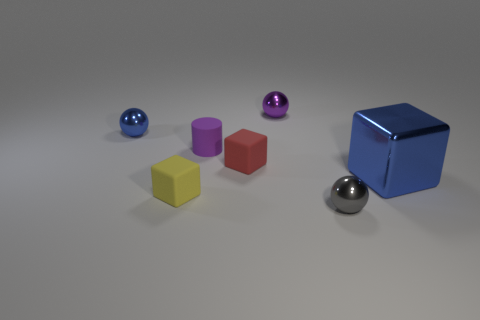Add 3 blue cubes. How many objects exist? 10 Subtract all cylinders. How many objects are left? 6 Add 3 small gray shiny spheres. How many small gray shiny spheres exist? 4 Subtract 0 green spheres. How many objects are left? 7 Subtract all gray objects. Subtract all big blue metallic blocks. How many objects are left? 5 Add 7 purple shiny objects. How many purple shiny objects are left? 8 